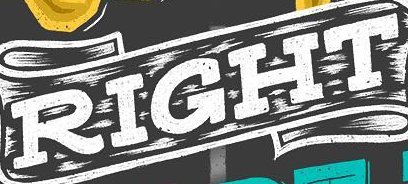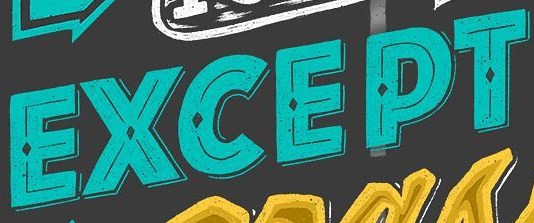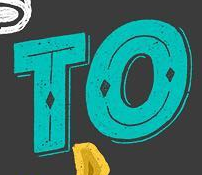Identify the words shown in these images in order, separated by a semicolon. RIGHT; EXCEPT; TO 